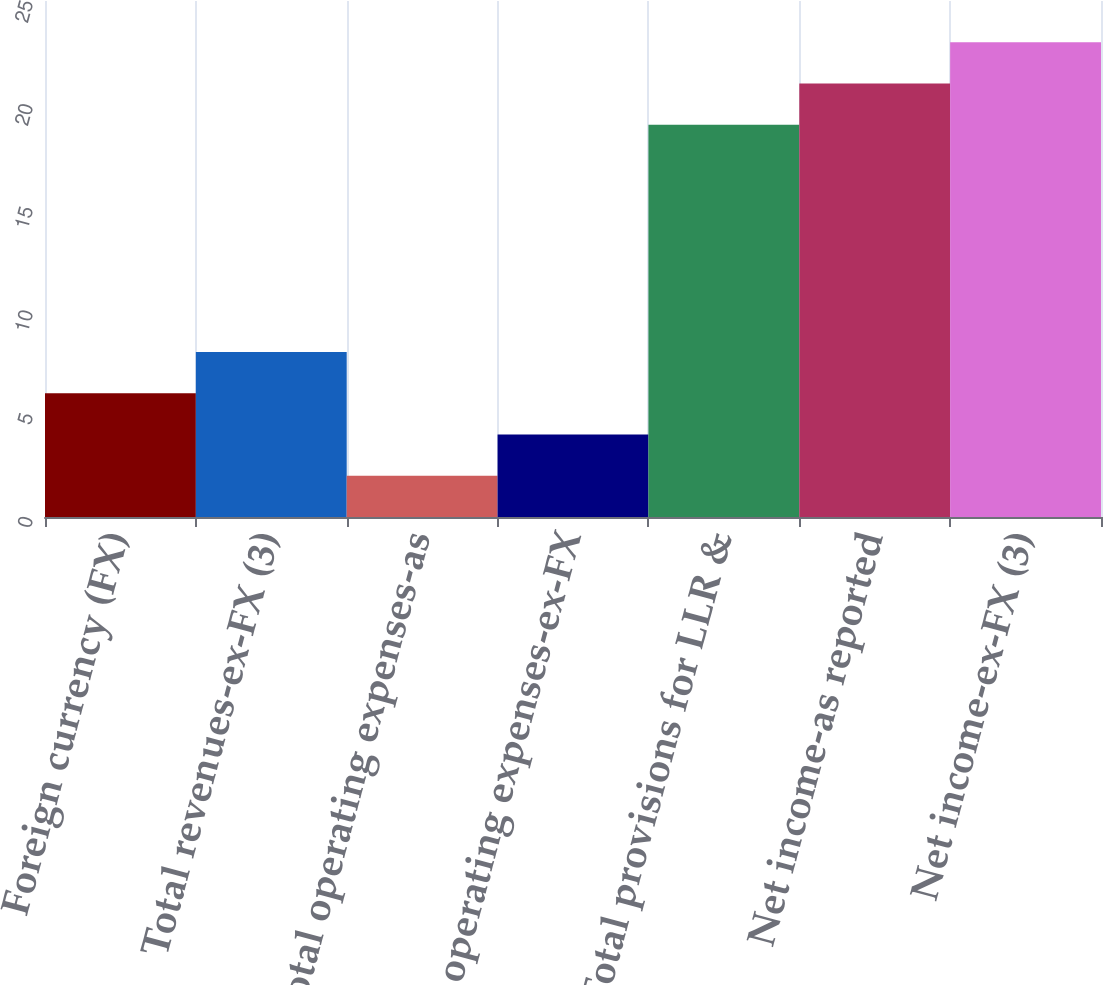Convert chart to OTSL. <chart><loc_0><loc_0><loc_500><loc_500><bar_chart><fcel>Foreign currency (FX)<fcel>Total revenues-ex-FX (3)<fcel>Total operating expenses-as<fcel>Total operating expenses-ex-FX<fcel>Total provisions for LLR &<fcel>Net income-as reported<fcel>Net income-ex-FX (3)<nl><fcel>6<fcel>8<fcel>2<fcel>4<fcel>19<fcel>21<fcel>23<nl></chart> 